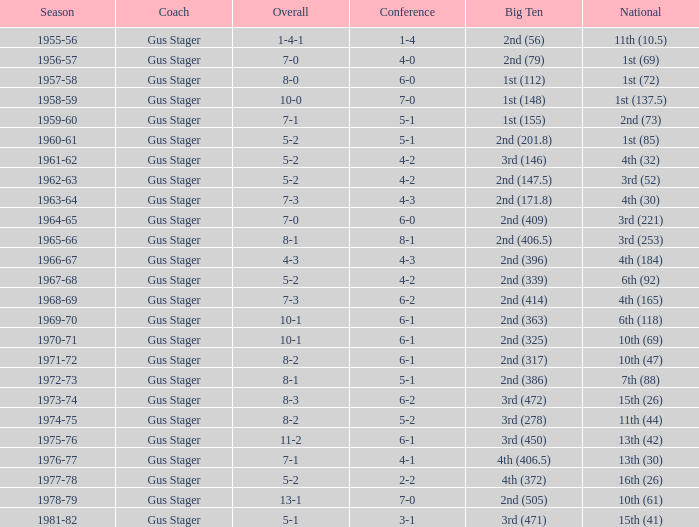What is the Season with a Big Ten that is 2nd (386)? 1972-73. 